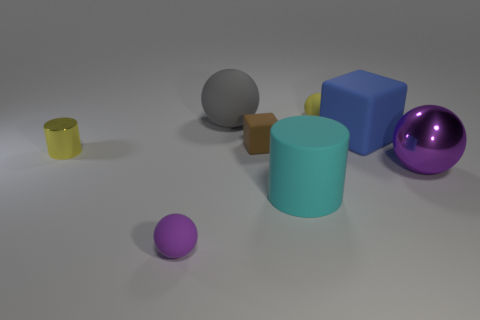What material is the other tiny object that is the same color as the tiny metallic thing?
Provide a short and direct response. Rubber. There is a rubber thing that is the same color as the big metallic ball; what size is it?
Provide a short and direct response. Small. Is the material of the tiny yellow object that is in front of the small yellow matte thing the same as the large purple object?
Make the answer very short. Yes. What is the color of the big rubber object that is the same shape as the purple metallic object?
Your response must be concise. Gray. There is a gray rubber object; what shape is it?
Keep it short and to the point. Sphere. What number of things are tiny metallic objects or purple cubes?
Offer a terse response. 1. Do the tiny matte sphere behind the yellow metal cylinder and the metallic object that is to the left of the big cyan matte thing have the same color?
Provide a succinct answer. Yes. What number of other objects are the same shape as the gray matte thing?
Your answer should be very brief. 3. Are there any small purple metal spheres?
Your answer should be compact. No. What number of objects are big green cubes or tiny objects behind the big purple metal sphere?
Give a very brief answer. 3. 